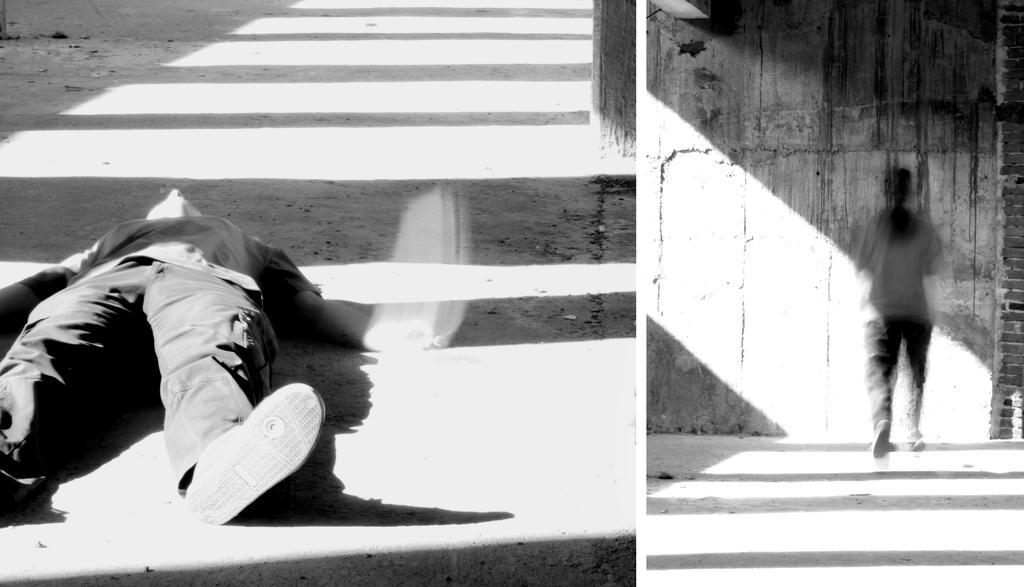In one or two sentences, can you explain what this image depicts? This is a black and white image. In this image we can see a collages of a person's. 